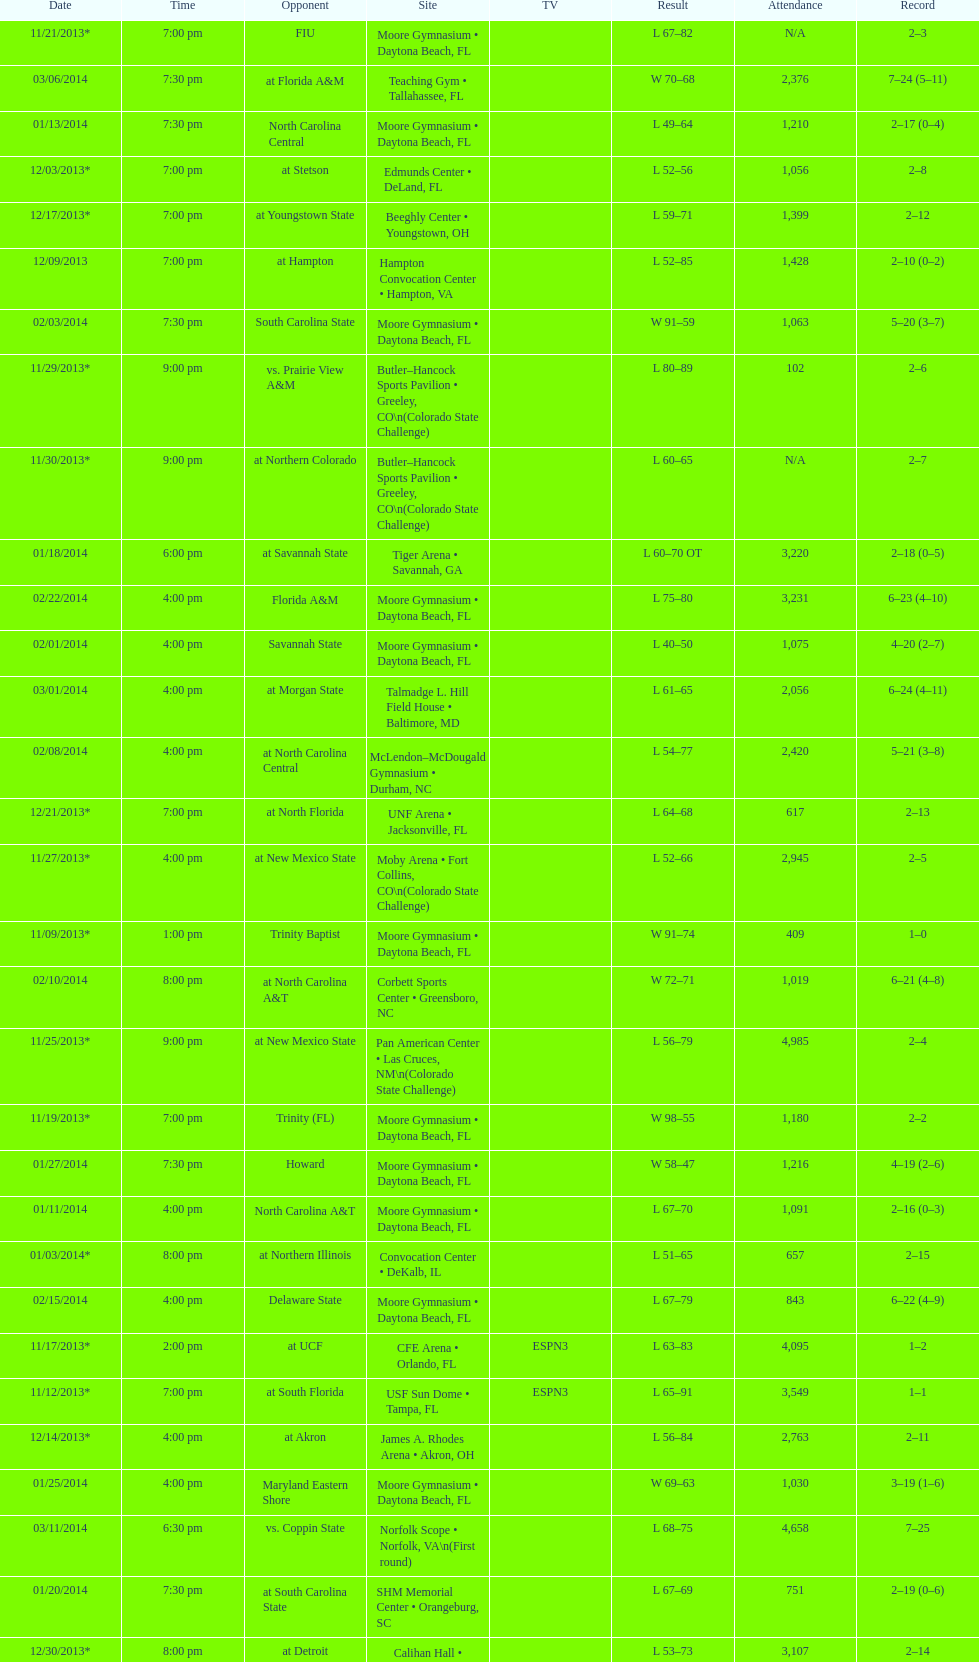Which game was won by a bigger margin, against trinity (fl) or against trinity baptist? Trinity (FL). 